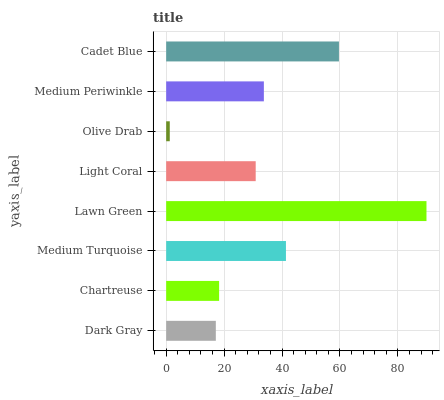Is Olive Drab the minimum?
Answer yes or no. Yes. Is Lawn Green the maximum?
Answer yes or no. Yes. Is Chartreuse the minimum?
Answer yes or no. No. Is Chartreuse the maximum?
Answer yes or no. No. Is Chartreuse greater than Dark Gray?
Answer yes or no. Yes. Is Dark Gray less than Chartreuse?
Answer yes or no. Yes. Is Dark Gray greater than Chartreuse?
Answer yes or no. No. Is Chartreuse less than Dark Gray?
Answer yes or no. No. Is Medium Periwinkle the high median?
Answer yes or no. Yes. Is Light Coral the low median?
Answer yes or no. Yes. Is Light Coral the high median?
Answer yes or no. No. Is Olive Drab the low median?
Answer yes or no. No. 